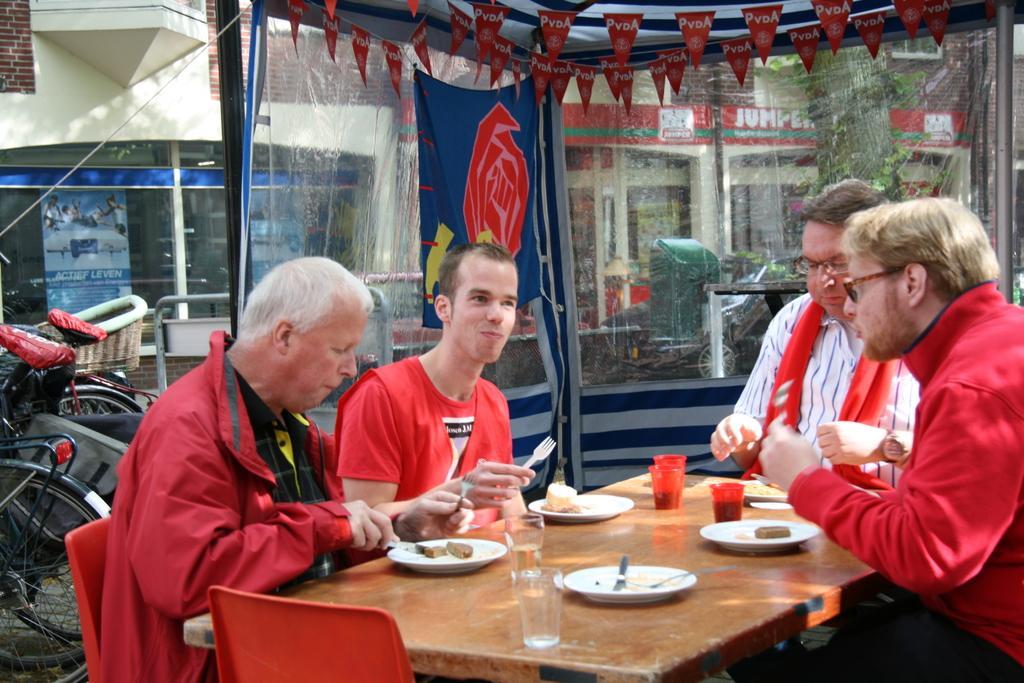How would you summarize this image in a sentence or two? There are four members who are men sitting around the table in the chairs. On the table there are food items and glasses. In the background there are bicycles and some buildings. There is a trash bin and some tree here. 